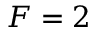Convert formula to latex. <formula><loc_0><loc_0><loc_500><loc_500>F = 2</formula> 